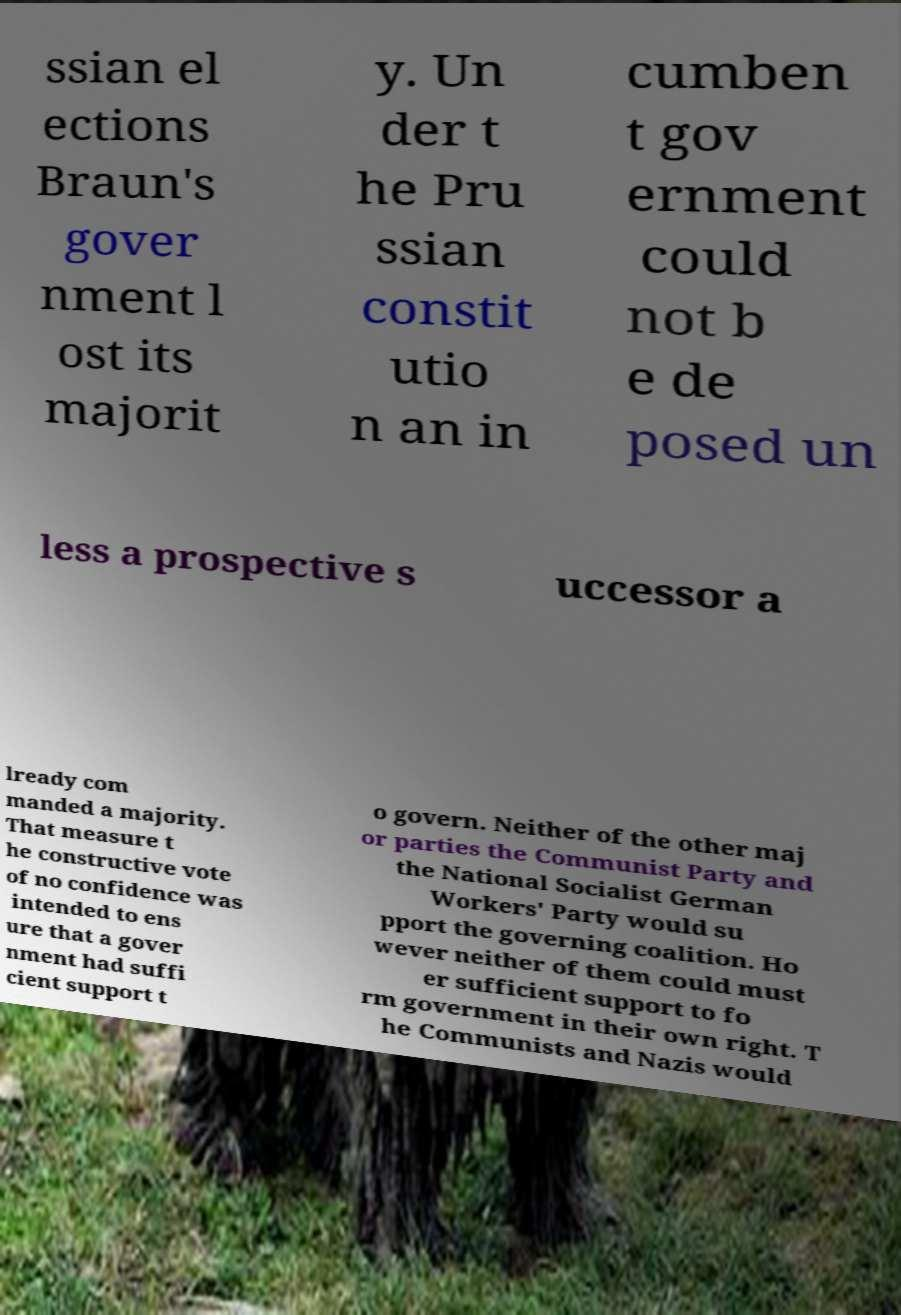There's text embedded in this image that I need extracted. Can you transcribe it verbatim? ssian el ections Braun's gover nment l ost its majorit y. Un der t he Pru ssian constit utio n an in cumben t gov ernment could not b e de posed un less a prospective s uccessor a lready com manded a majority. That measure t he constructive vote of no confidence was intended to ens ure that a gover nment had suffi cient support t o govern. Neither of the other maj or parties the Communist Party and the National Socialist German Workers' Party would su pport the governing coalition. Ho wever neither of them could must er sufficient support to fo rm government in their own right. T he Communists and Nazis would 